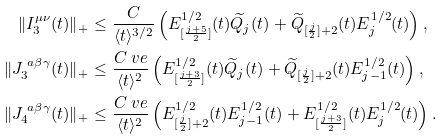<formula> <loc_0><loc_0><loc_500><loc_500>\| I _ { 3 } ^ { \mu \nu } ( t ) \| _ { + } & \leq \frac { C } { \langle t \rangle ^ { 3 / 2 } } \left ( E ^ { 1 / 2 } _ { [ \frac { j + 5 } { 2 } ] } ( t ) \widetilde { Q } _ { j } ( t ) + \widetilde { Q } _ { [ \frac { j } { 2 } ] + 2 } ( t ) E _ { j } ^ { 1 / 2 } ( t ) \right ) , \\ \| J _ { 3 } ^ { \ a \beta \gamma } ( t ) \| _ { + } & \leq \frac { C \ v e } { \langle t \rangle ^ { 2 } } \left ( E ^ { 1 / 2 } _ { [ \frac { j + 3 } { 2 } ] } ( t ) \widetilde { Q } _ { j } ( t ) + \widetilde { Q } _ { [ \frac { j } { 2 } ] + 2 } ( t ) E _ { j - 1 } ^ { 1 / 2 } ( t ) \right ) , \\ \| J _ { 4 } ^ { \ a \beta \gamma } ( t ) \| _ { + } & \leq \frac { C \ v e } { \langle t \rangle ^ { 2 } } \left ( E ^ { 1 / 2 } _ { [ \frac { j } { 2 } ] + 2 } ( t ) E ^ { 1 / 2 } _ { j - 1 } ( t ) + E ^ { 1 / 2 } _ { [ \frac { j + 3 } { 2 } ] } ( t ) E _ { j } ^ { 1 / 2 } ( t ) \right ) .</formula> 